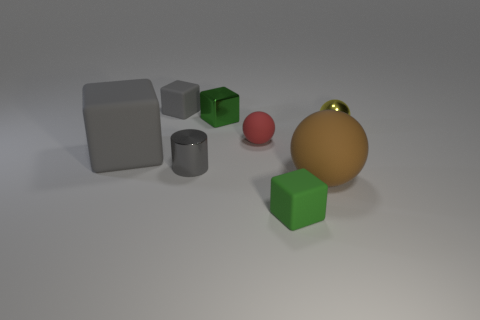Subtract all green rubber cubes. How many cubes are left? 3 Add 1 small shiny cylinders. How many objects exist? 9 Subtract all gray cubes. How many cubes are left? 2 Subtract all purple balls. How many green cubes are left? 2 Subtract all cylinders. How many objects are left? 7 Subtract 2 blocks. How many blocks are left? 2 Add 6 balls. How many balls are left? 9 Add 1 yellow shiny objects. How many yellow shiny objects exist? 2 Subtract 0 red cubes. How many objects are left? 8 Subtract all cyan balls. Subtract all cyan cylinders. How many balls are left? 3 